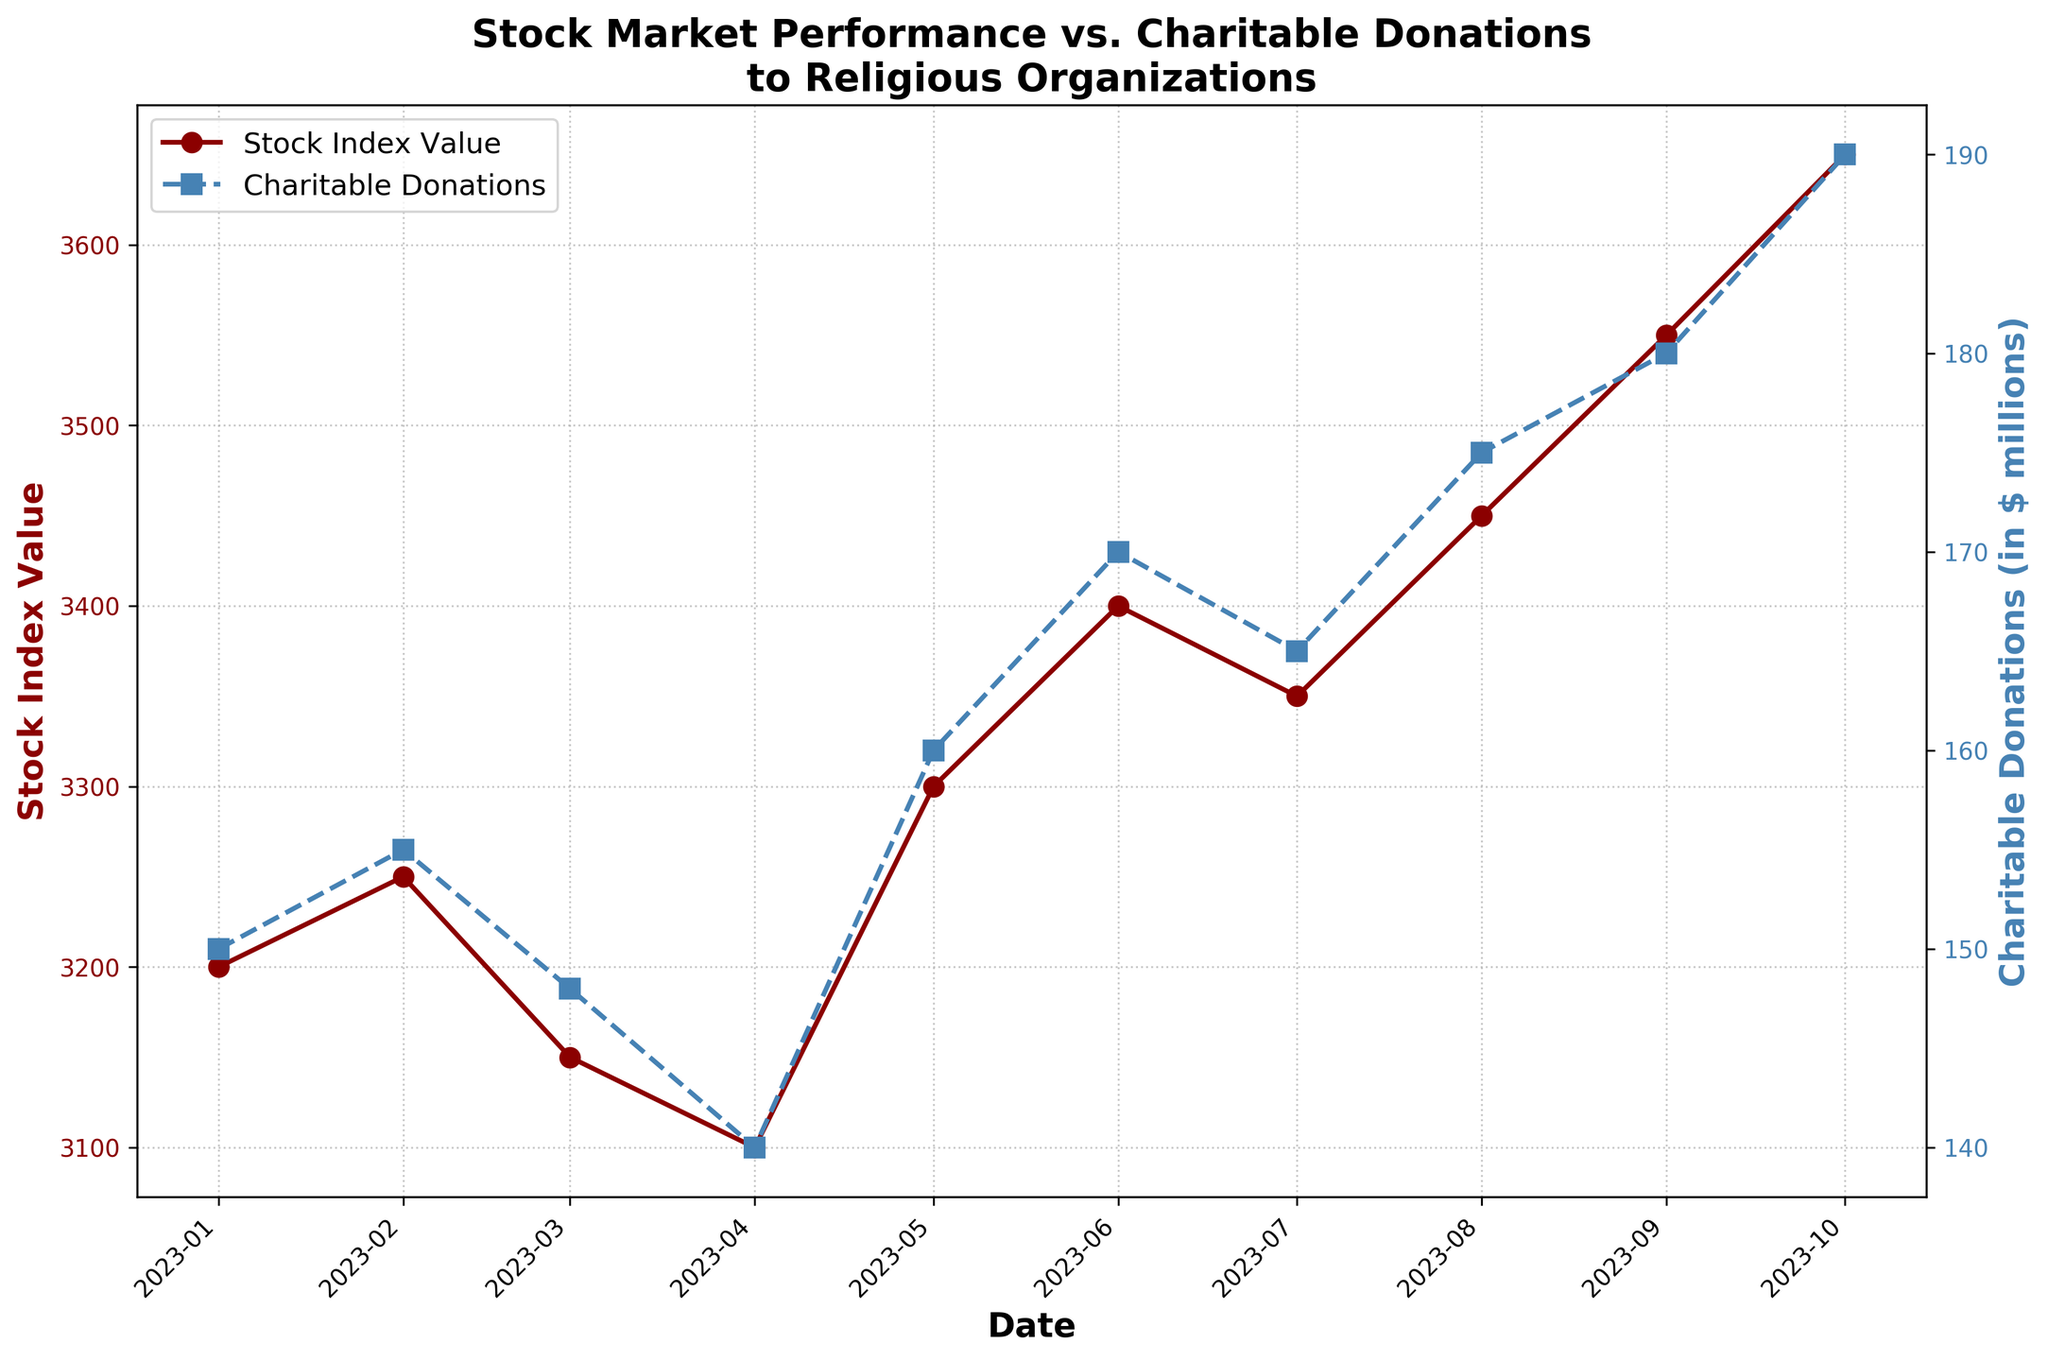How many data points are there for the Stock Index Value? The timeline on the x-axis shows monthly data points from January 2023 to October 2023. By counting each month, we identify a total of 10 data points.
Answer: 10 What is the trend of the Stock Index Value over the given period? The Stock Index Value starts at 3200 in January, slightly fluctuates, and generally increases to 3650 by October. This indicates an overall upward trend.
Answer: Upward trend How do the charitable donations to religious organizations change from January to October? The donations start at $150 million in January and exhibit a steady increase over the months, reaching $190 million in October.
Answer: Steady increase What is the Stock Index Value in May 2023 compared to March 2023? In March, the Stock Index Value is 3150, and in May, it is 3300. The value increased by 150 points.
Answer: Increased by 150 points During which month did the Charitable Donations to Religious Organizations experience the highest growth compared to the previous month? August had $175 million, and September had $180 million, which is the highest month-over-month increase of $5 million.
Answer: September What was the Stock Index Value when Charitable Donations first reached $170 million? Charitable donations first reached $170 million in June 2023 when the Stock Index Value was 3400.
Answer: 3400 What is the percentage increase in Charitable Donations from January to October? The donations started at $150 million in January and grew to $190 million in October. The percentage increase is calculated as \(\frac{190 - 150}{150} \times 100 = 26.67\%\).
Answer: 26.67% Compare the Stock Index Value and Charitable Donations in July 2023. Were they both increasing or decreasing compared to June 2023? The Stock Index Value decreased from 3400 in June to 3350 in July. However, Charitable Donations decreased from $170 million in June to $165 million in July. So, both were decreasing.
Answer: Decreasing What can be inferred about the correlation between Stock Index Value and Charitable Donations based on the plot? Both the Stock Index Value and Charitable Donations generally increase over the months. This suggests a positive correlation where higher stock market performance might support higher donations.
Answer: Positive correlation Calculate the average Charitable Donations over the entire period. Sum of donations from January to October: 150 + 155 + 148 + 140 + 160 + 170 + 165 + 175 + 180 + 190 = 1633 million. The average is \( \frac{1633}{10} = 163.3 \) million.
Answer: 163.3 million 